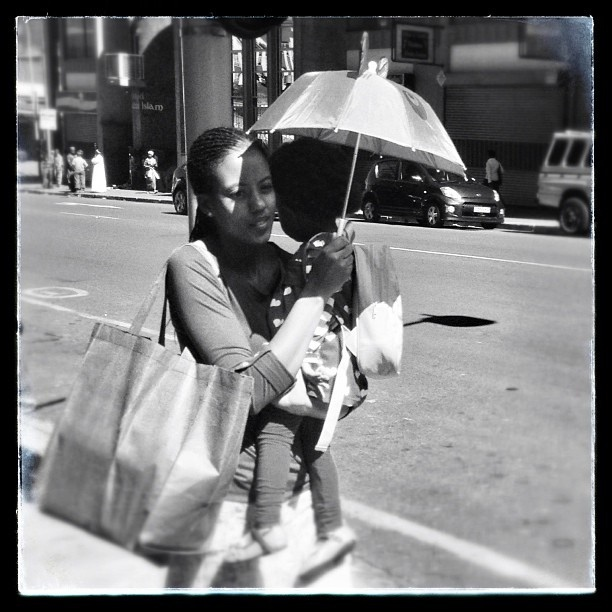Describe the objects in this image and their specific colors. I can see people in black, lightgray, darkgray, and gray tones, handbag in black, darkgray, gray, and lightgray tones, people in black, darkgray, white, and gray tones, umbrella in black, lightgray, darkgray, and gray tones, and car in black, gray, white, and darkgray tones in this image. 